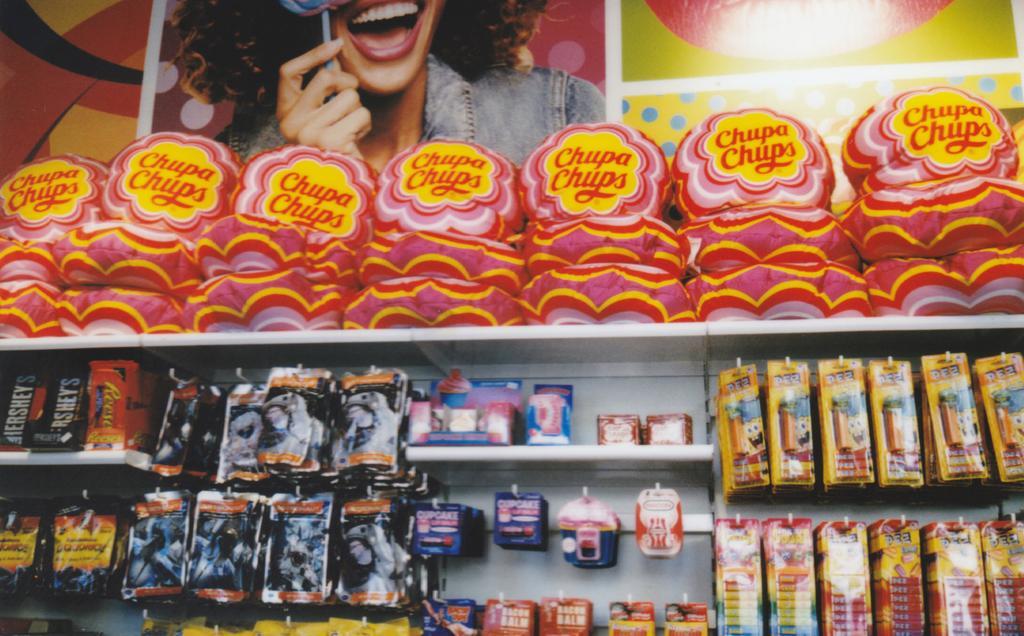In one or two sentences, can you explain what this image depicts? i can see a store in which chocolates are available and a lady in the image holding a chocolate and smiling and i can few others things which are available in the store. 